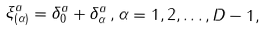Convert formula to latex. <formula><loc_0><loc_0><loc_500><loc_500>\xi ^ { a } _ { ( \alpha ) } = \delta ^ { a } _ { 0 } + \delta ^ { a } _ { \alpha } \, , \alpha = 1 , 2 , \dots , D - 1 ,</formula> 